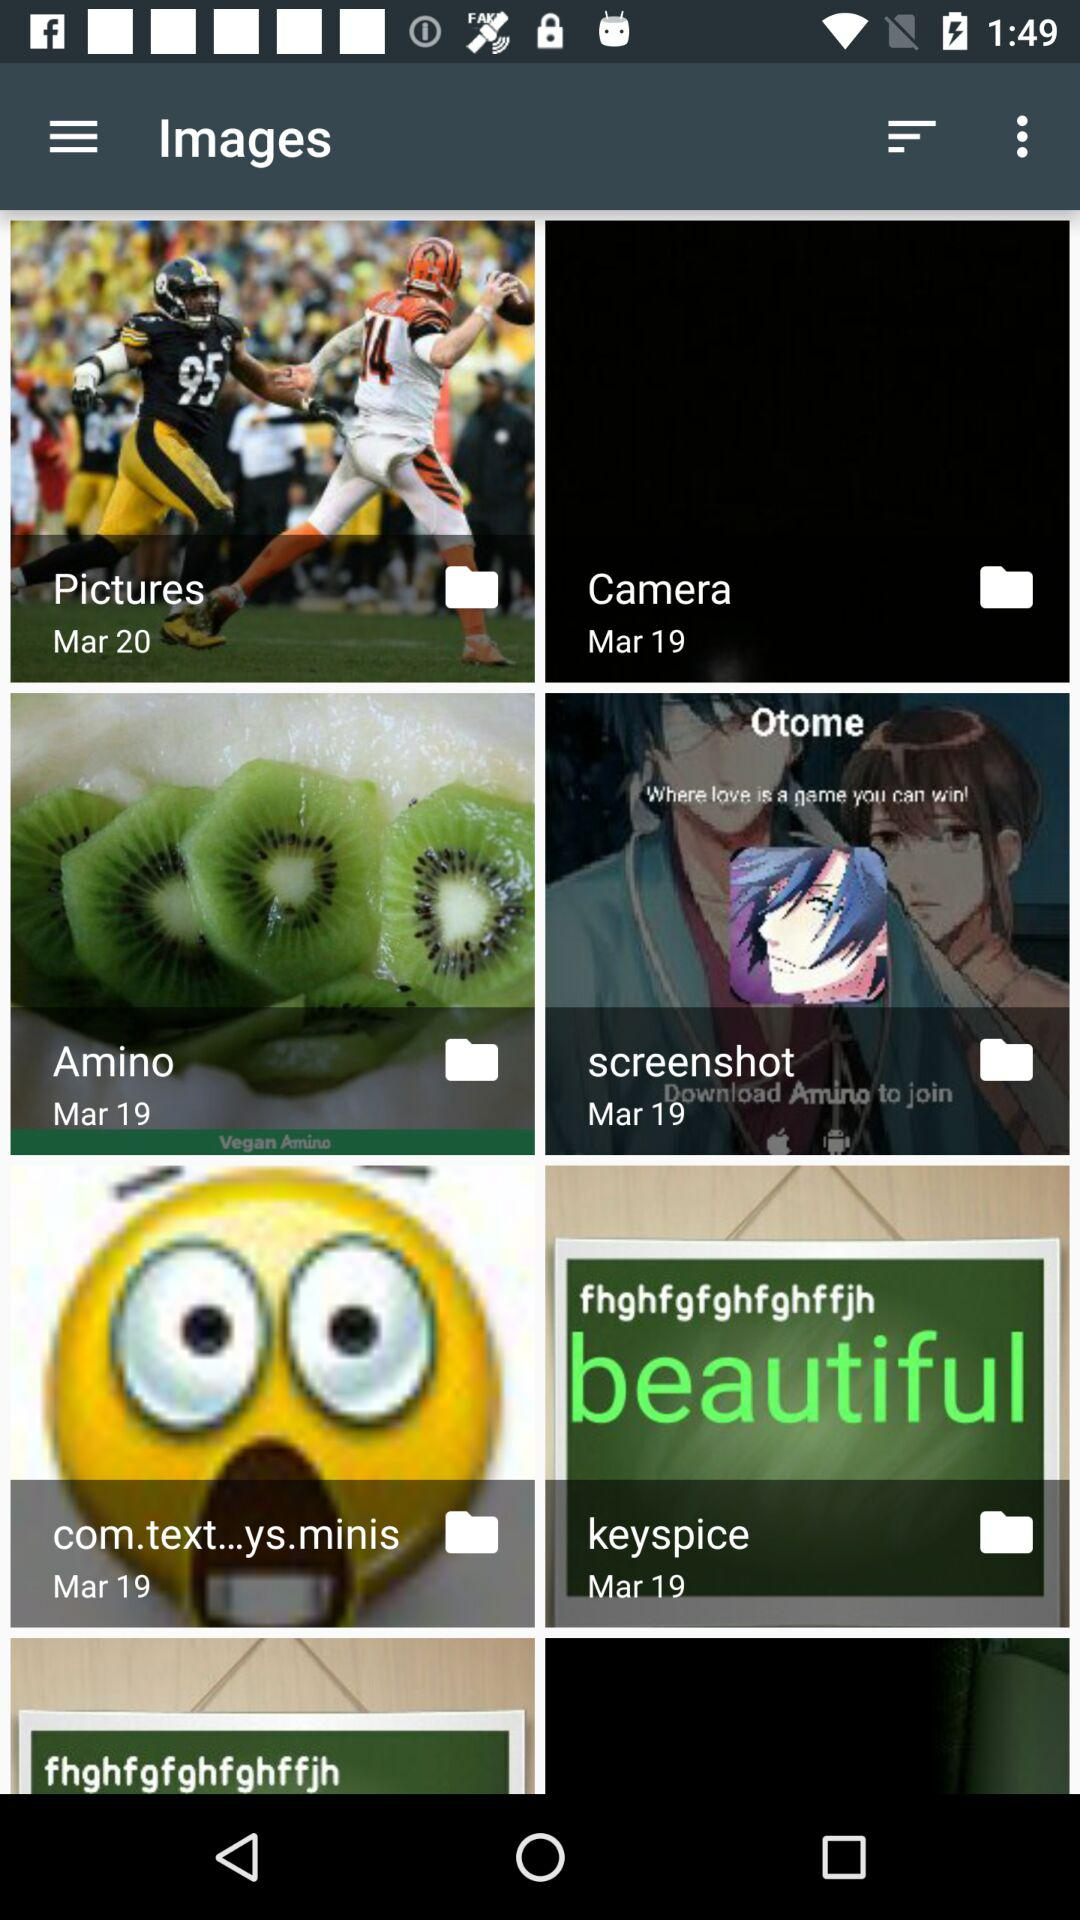What is "Amino" folder's date? The date of "Amino" folder is March 19. 